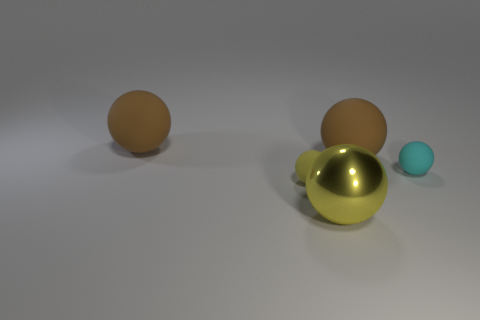What number of brown rubber things are the same shape as the big metallic thing? 2 